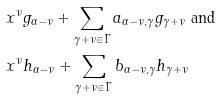<formula> <loc_0><loc_0><loc_500><loc_500>& x ^ { \nu } g _ { \alpha - \nu } + \sum _ { \gamma + \nu \in \Gamma } a _ { \alpha - \nu , \gamma } g _ { \gamma + \nu } \text { and} \\ & x ^ { \nu } h _ { \alpha - \nu } + \sum _ { \gamma + \nu \in \Gamma } b _ { \alpha - \nu , \gamma } h _ { \gamma + \nu }</formula> 